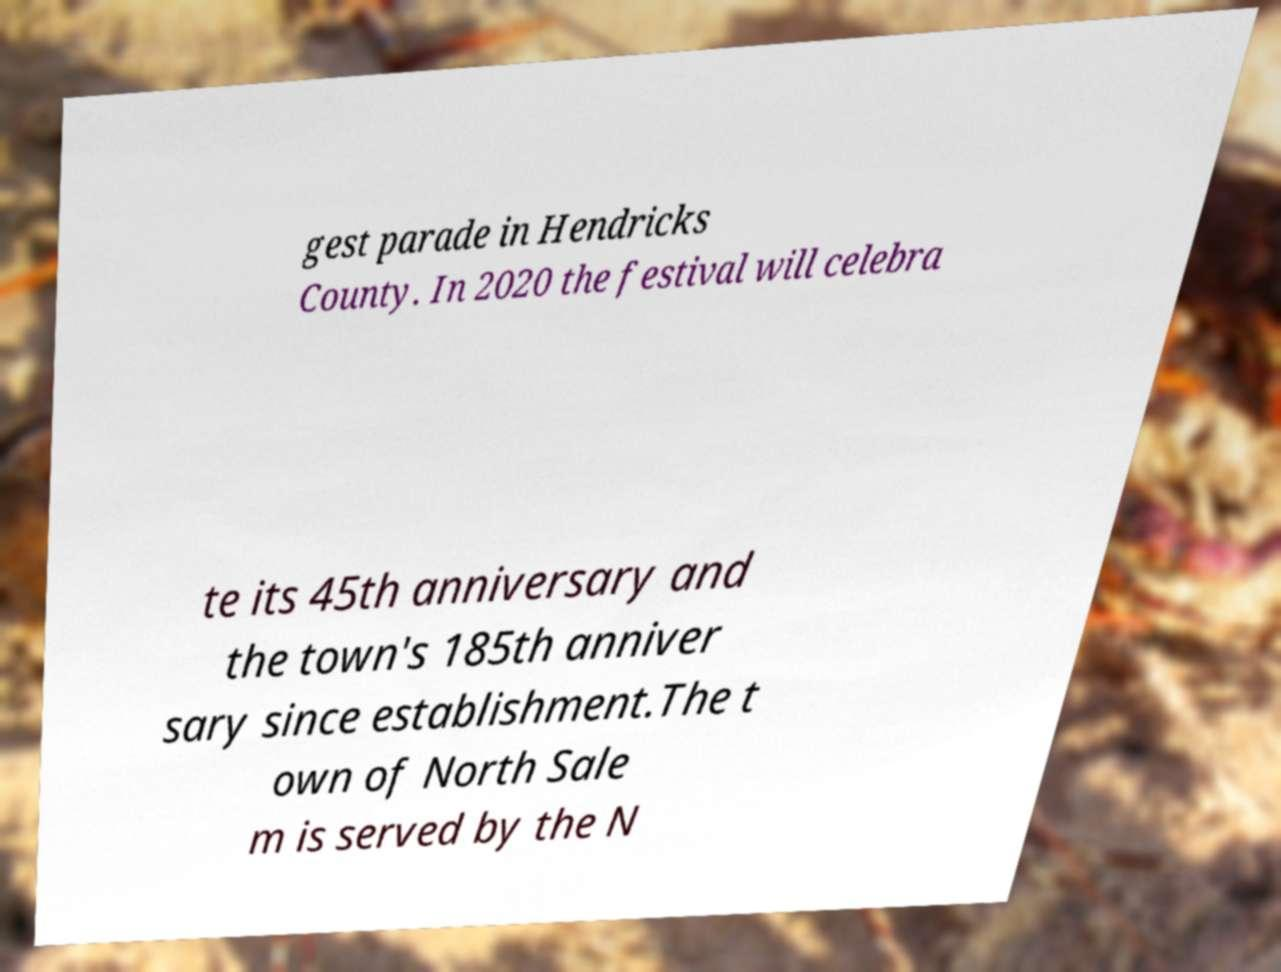What messages or text are displayed in this image? I need them in a readable, typed format. gest parade in Hendricks County. In 2020 the festival will celebra te its 45th anniversary and the town's 185th anniver sary since establishment.The t own of North Sale m is served by the N 